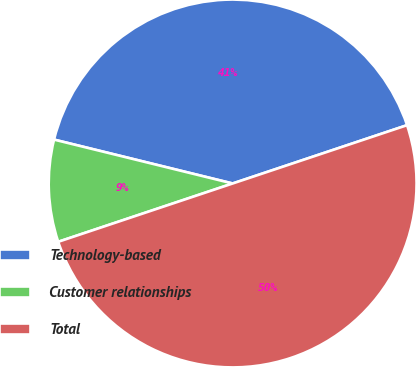<chart> <loc_0><loc_0><loc_500><loc_500><pie_chart><fcel>Technology-based<fcel>Customer relationships<fcel>Total<nl><fcel>41.03%<fcel>8.97%<fcel>50.0%<nl></chart> 